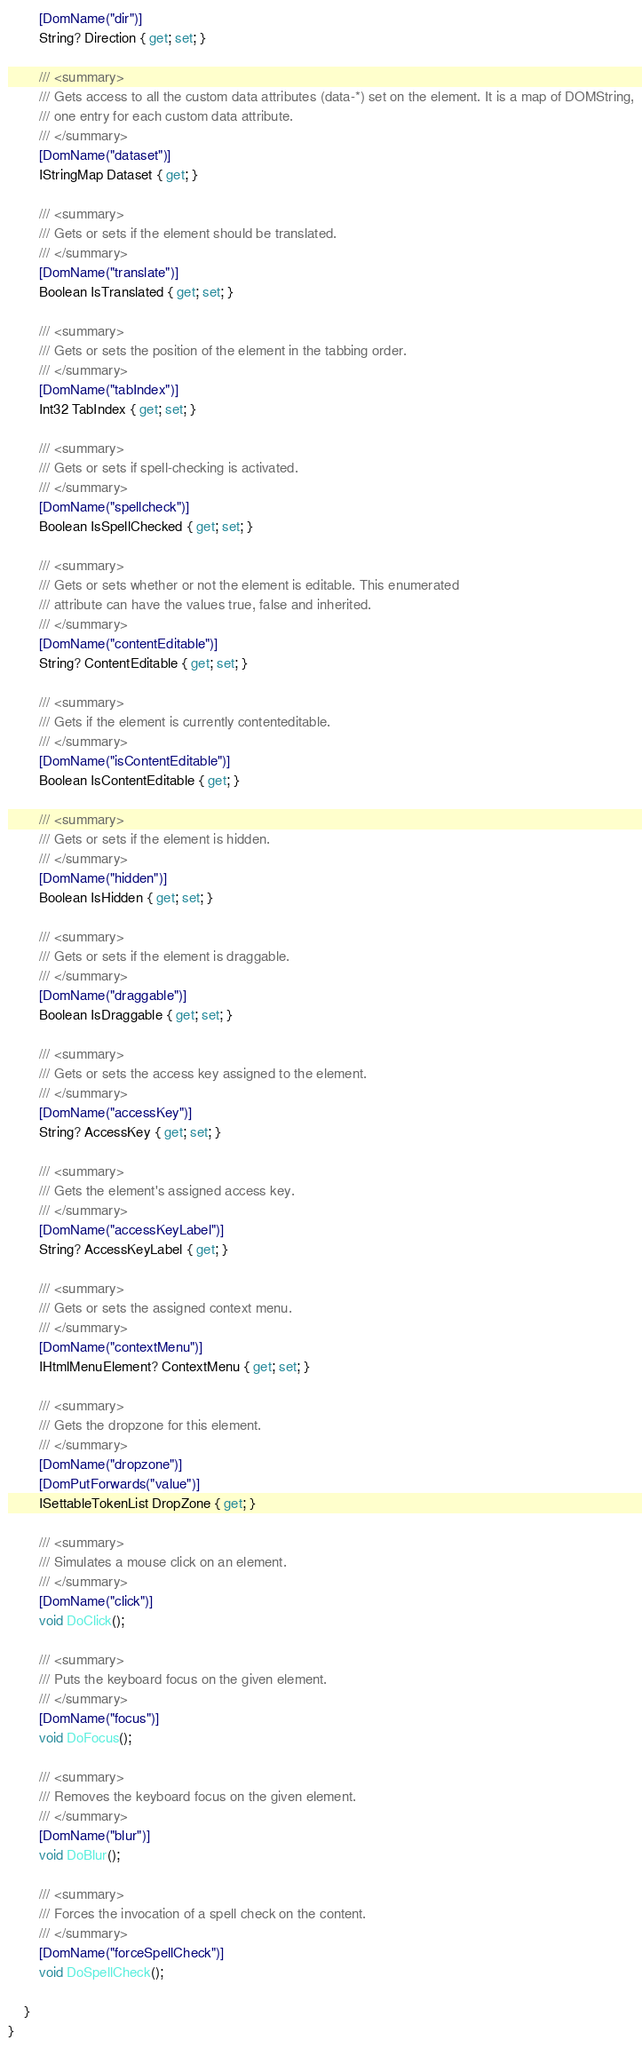<code> <loc_0><loc_0><loc_500><loc_500><_C#_>        [DomName("dir")]
        String? Direction { get; set; }

        /// <summary>
        /// Gets access to all the custom data attributes (data-*) set on the element. It is a map of DOMString,
        /// one entry for each custom data attribute.
        /// </summary>
        [DomName("dataset")]
        IStringMap Dataset { get; }

        /// <summary>
        /// Gets or sets if the element should be translated.
        /// </summary>
        [DomName("translate")]
        Boolean IsTranslated { get; set; }

        /// <summary>
        /// Gets or sets the position of the element in the tabbing order.
        /// </summary>
        [DomName("tabIndex")]
        Int32 TabIndex { get; set; }

        /// <summary>
        /// Gets or sets if spell-checking is activated.
        /// </summary>
        [DomName("spellcheck")]
        Boolean IsSpellChecked { get; set; }

        /// <summary>
        /// Gets or sets whether or not the element is editable. This enumerated
        /// attribute can have the values true, false and inherited.
        /// </summary>
        [DomName("contentEditable")]
        String? ContentEditable { get; set; }

        /// <summary>
        /// Gets if the element is currently contenteditable.
        /// </summary>
        [DomName("isContentEditable")]
        Boolean IsContentEditable { get; }

        /// <summary>
        /// Gets or sets if the element is hidden.
        /// </summary>
        [DomName("hidden")]
        Boolean IsHidden { get; set; }

        /// <summary>
        /// Gets or sets if the element is draggable.
        /// </summary>
        [DomName("draggable")]
        Boolean IsDraggable { get; set; }

        /// <summary>
        /// Gets or sets the access key assigned to the element.
        /// </summary>
        [DomName("accessKey")]
        String? AccessKey { get; set; }

        /// <summary>
        /// Gets the element's assigned access key.
        /// </summary>
        [DomName("accessKeyLabel")]
        String? AccessKeyLabel { get; }

        /// <summary>
        /// Gets or sets the assigned context menu.
        /// </summary>
        [DomName("contextMenu")]
        IHtmlMenuElement? ContextMenu { get; set; }

        /// <summary>
        /// Gets the dropzone for this element.
        /// </summary>
        [DomName("dropzone")]
        [DomPutForwards("value")]
        ISettableTokenList DropZone { get; }

        /// <summary>
        /// Simulates a mouse click on an element.
        /// </summary>
        [DomName("click")]
        void DoClick();

        /// <summary>
        /// Puts the keyboard focus on the given element.
        /// </summary>
        [DomName("focus")]
        void DoFocus();

        /// <summary>
        /// Removes the keyboard focus on the given element.
        /// </summary>
        [DomName("blur")]
        void DoBlur();

        /// <summary>
        /// Forces the invocation of a spell check on the content.
        /// </summary>
        [DomName("forceSpellCheck")]
        void DoSpellCheck();

    }
}
</code> 